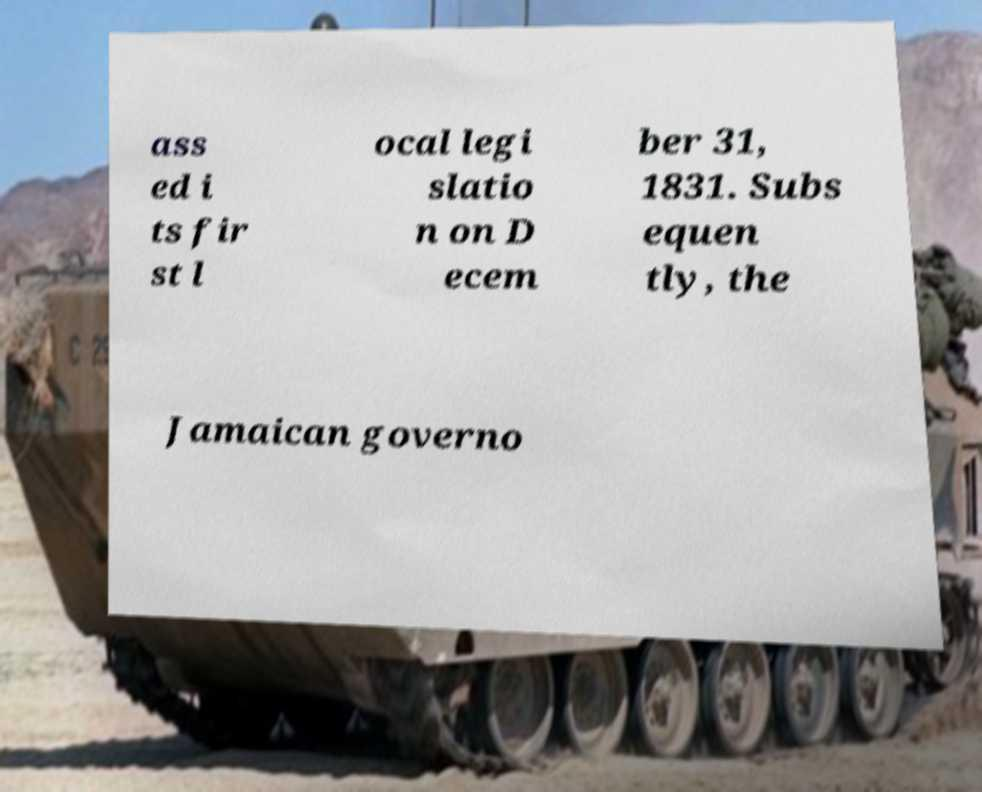For documentation purposes, I need the text within this image transcribed. Could you provide that? ass ed i ts fir st l ocal legi slatio n on D ecem ber 31, 1831. Subs equen tly, the Jamaican governo 